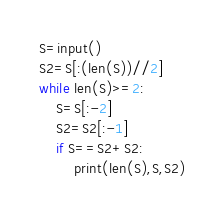Convert code to text. <code><loc_0><loc_0><loc_500><loc_500><_Python_>S=input()
S2=S[:(len(S))//2]
while len(S)>=2:
    S=S[:-2]
    S2=S2[:-1]
    if S==S2+S2:
        print(len(S),S,S2)
</code> 